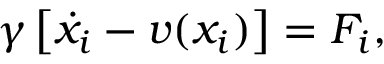Convert formula to latex. <formula><loc_0><loc_0><loc_500><loc_500>\begin{array} { r } { \gamma \left [ \dot { x } _ { i } - v ( x _ { i } ) \right ] = F _ { i } , } \end{array}</formula> 